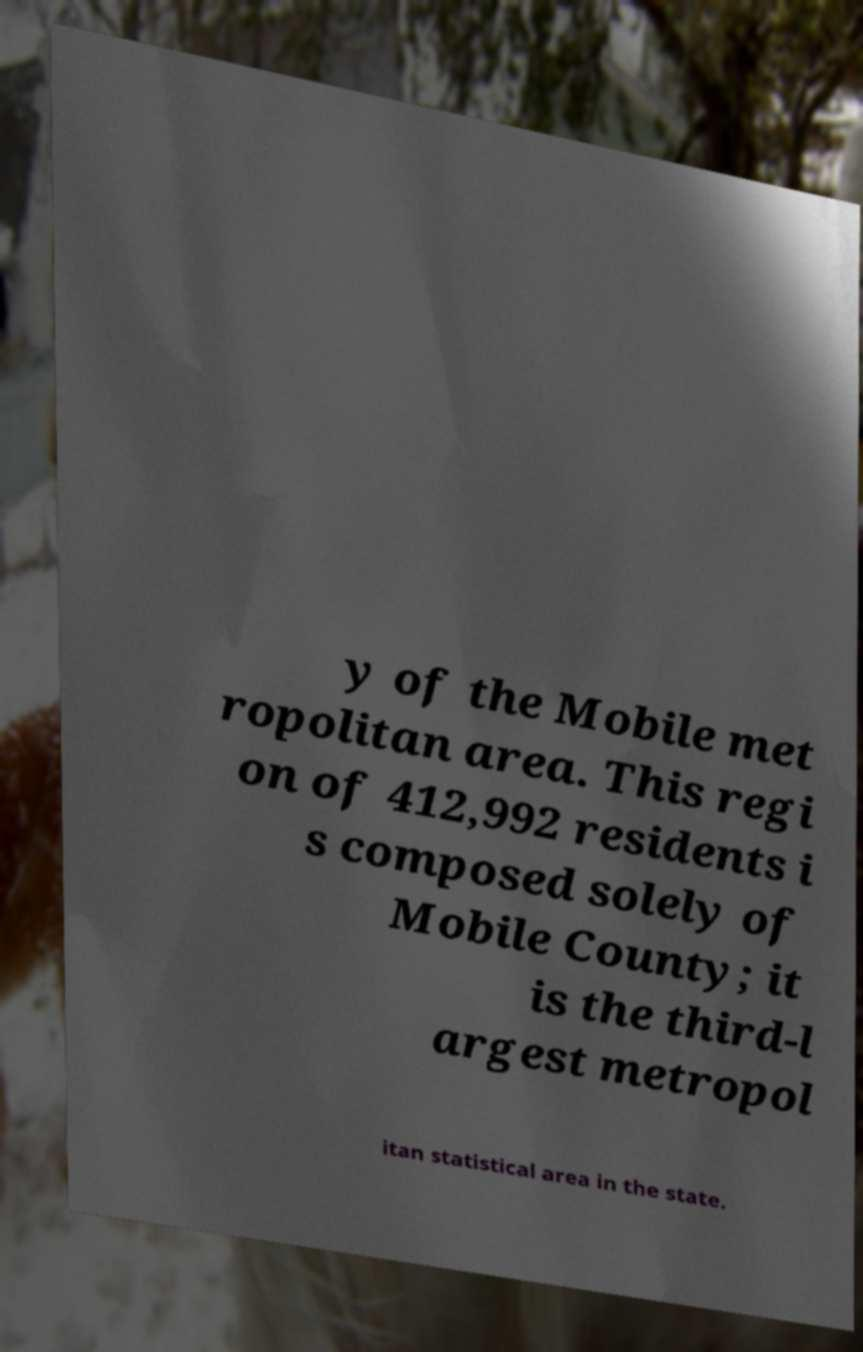Could you assist in decoding the text presented in this image and type it out clearly? y of the Mobile met ropolitan area. This regi on of 412,992 residents i s composed solely of Mobile County; it is the third-l argest metropol itan statistical area in the state. 